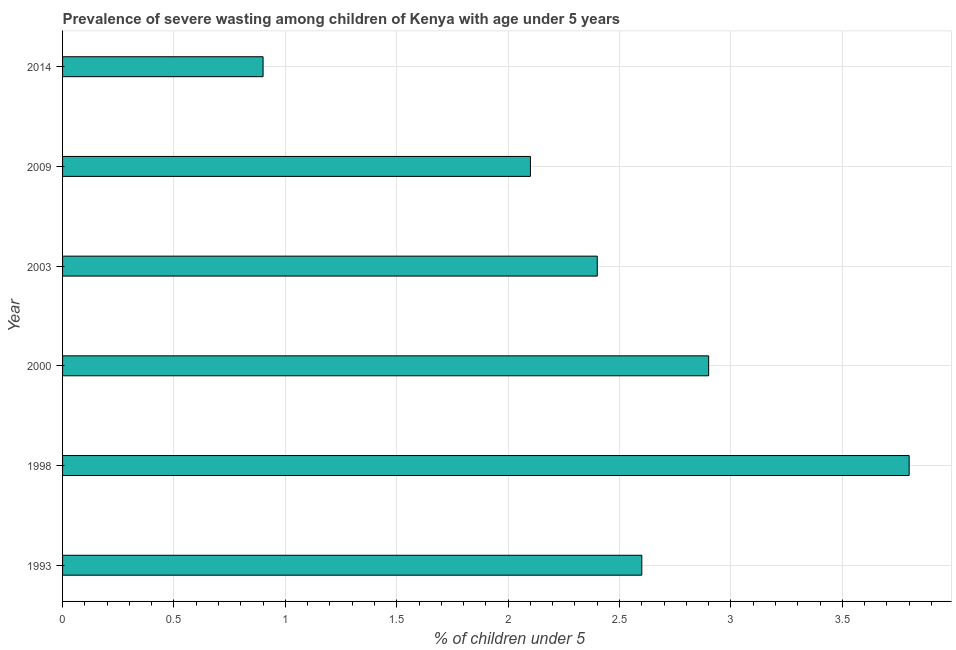Does the graph contain grids?
Provide a succinct answer. Yes. What is the title of the graph?
Your answer should be compact. Prevalence of severe wasting among children of Kenya with age under 5 years. What is the label or title of the X-axis?
Keep it short and to the point.  % of children under 5. What is the label or title of the Y-axis?
Your answer should be compact. Year. What is the prevalence of severe wasting in 2003?
Provide a succinct answer. 2.4. Across all years, what is the maximum prevalence of severe wasting?
Ensure brevity in your answer.  3.8. Across all years, what is the minimum prevalence of severe wasting?
Offer a very short reply. 0.9. In which year was the prevalence of severe wasting maximum?
Provide a succinct answer. 1998. What is the sum of the prevalence of severe wasting?
Your answer should be compact. 14.7. What is the difference between the prevalence of severe wasting in 1993 and 2000?
Ensure brevity in your answer.  -0.3. What is the average prevalence of severe wasting per year?
Your response must be concise. 2.45. What is the ratio of the prevalence of severe wasting in 2000 to that in 2014?
Keep it short and to the point. 3.22. Is the prevalence of severe wasting in 2000 less than that in 2003?
Provide a short and direct response. No. Is the difference between the prevalence of severe wasting in 1993 and 2000 greater than the difference between any two years?
Make the answer very short. No. What is the difference between the highest and the second highest prevalence of severe wasting?
Provide a short and direct response. 0.9. What is the difference between the highest and the lowest prevalence of severe wasting?
Make the answer very short. 2.9. In how many years, is the prevalence of severe wasting greater than the average prevalence of severe wasting taken over all years?
Provide a succinct answer. 3. Are all the bars in the graph horizontal?
Provide a succinct answer. Yes. How many years are there in the graph?
Provide a short and direct response. 6. What is the difference between two consecutive major ticks on the X-axis?
Give a very brief answer. 0.5. What is the  % of children under 5 of 1993?
Ensure brevity in your answer.  2.6. What is the  % of children under 5 in 1998?
Provide a succinct answer. 3.8. What is the  % of children under 5 in 2000?
Keep it short and to the point. 2.9. What is the  % of children under 5 in 2003?
Give a very brief answer. 2.4. What is the  % of children under 5 of 2009?
Offer a very short reply. 2.1. What is the  % of children under 5 of 2014?
Your answer should be compact. 0.9. What is the difference between the  % of children under 5 in 1993 and 1998?
Offer a very short reply. -1.2. What is the difference between the  % of children under 5 in 1993 and 2003?
Give a very brief answer. 0.2. What is the difference between the  % of children under 5 in 1998 and 2009?
Your response must be concise. 1.7. What is the difference between the  % of children under 5 in 2000 and 2014?
Ensure brevity in your answer.  2. What is the difference between the  % of children under 5 in 2003 and 2009?
Your response must be concise. 0.3. What is the ratio of the  % of children under 5 in 1993 to that in 1998?
Keep it short and to the point. 0.68. What is the ratio of the  % of children under 5 in 1993 to that in 2000?
Offer a terse response. 0.9. What is the ratio of the  % of children under 5 in 1993 to that in 2003?
Offer a very short reply. 1.08. What is the ratio of the  % of children under 5 in 1993 to that in 2009?
Offer a terse response. 1.24. What is the ratio of the  % of children under 5 in 1993 to that in 2014?
Give a very brief answer. 2.89. What is the ratio of the  % of children under 5 in 1998 to that in 2000?
Provide a succinct answer. 1.31. What is the ratio of the  % of children under 5 in 1998 to that in 2003?
Provide a short and direct response. 1.58. What is the ratio of the  % of children under 5 in 1998 to that in 2009?
Provide a short and direct response. 1.81. What is the ratio of the  % of children under 5 in 1998 to that in 2014?
Give a very brief answer. 4.22. What is the ratio of the  % of children under 5 in 2000 to that in 2003?
Your answer should be very brief. 1.21. What is the ratio of the  % of children under 5 in 2000 to that in 2009?
Ensure brevity in your answer.  1.38. What is the ratio of the  % of children under 5 in 2000 to that in 2014?
Make the answer very short. 3.22. What is the ratio of the  % of children under 5 in 2003 to that in 2009?
Offer a terse response. 1.14. What is the ratio of the  % of children under 5 in 2003 to that in 2014?
Offer a very short reply. 2.67. What is the ratio of the  % of children under 5 in 2009 to that in 2014?
Make the answer very short. 2.33. 